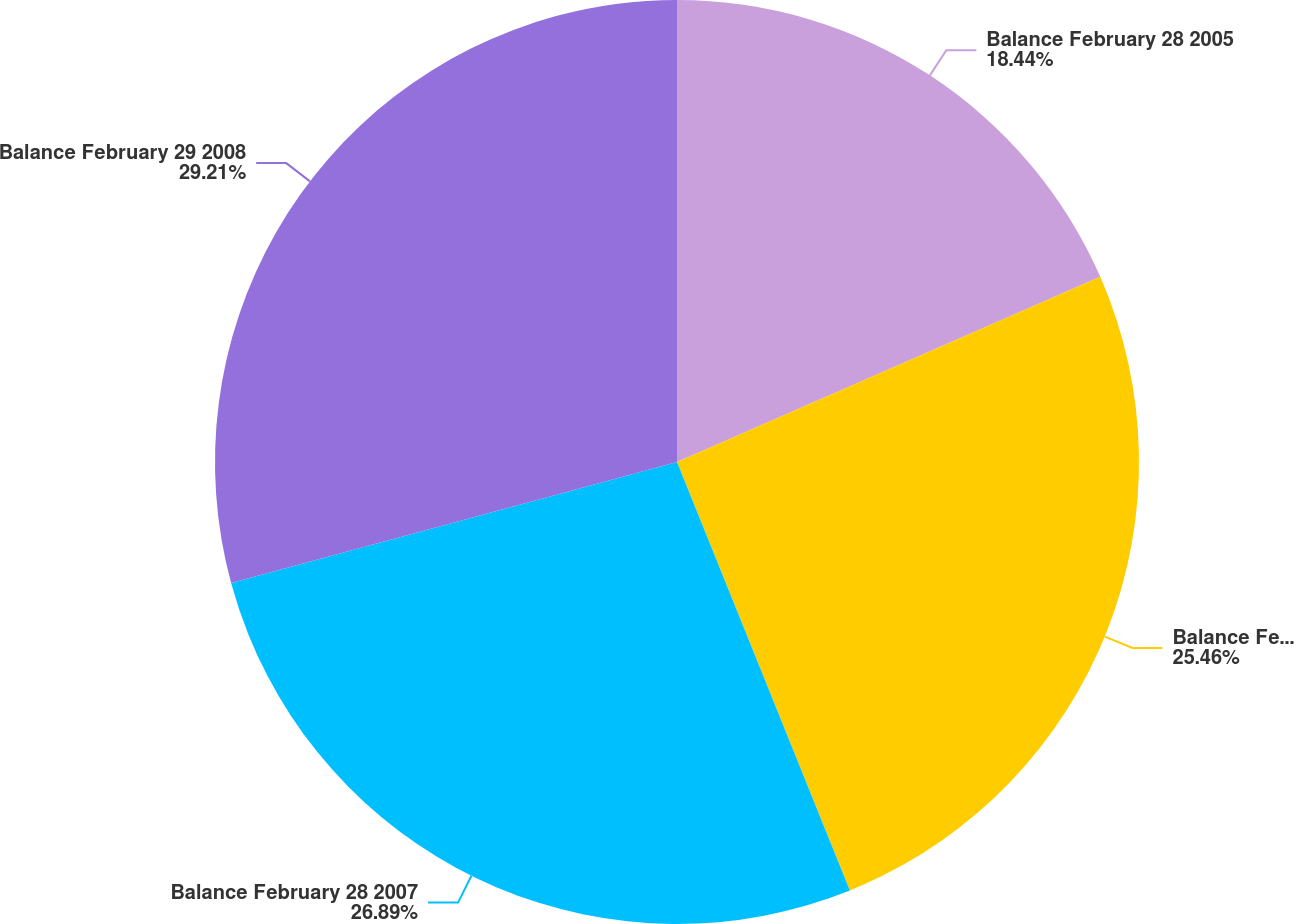<chart> <loc_0><loc_0><loc_500><loc_500><pie_chart><fcel>Balance February 28 2005<fcel>Balance February 28 2006<fcel>Balance February 28 2007<fcel>Balance February 29 2008<nl><fcel>18.44%<fcel>25.46%<fcel>26.89%<fcel>29.22%<nl></chart> 